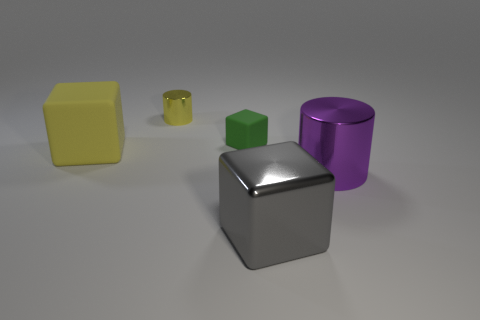What number of other things are the same color as the large metallic cylinder?
Your answer should be very brief. 0. There is a small thing that is to the left of the small matte block; does it have the same shape as the large yellow object?
Offer a very short reply. No. Is the number of big things behind the big gray block less than the number of small green rubber cylinders?
Offer a very short reply. No. Are there any yellow blocks made of the same material as the green block?
Provide a succinct answer. Yes. There is a purple object that is the same size as the gray block; what is it made of?
Give a very brief answer. Metal. Is the number of purple things in front of the big gray object less than the number of rubber blocks that are behind the yellow block?
Provide a short and direct response. Yes. There is a metallic object that is both left of the large purple cylinder and in front of the tiny green object; what is its shape?
Your answer should be very brief. Cube. How many big matte things are the same shape as the small matte object?
Your answer should be compact. 1. What size is the yellow block that is the same material as the tiny green object?
Ensure brevity in your answer.  Large. Is the number of small matte blocks greater than the number of blocks?
Offer a very short reply. No. 